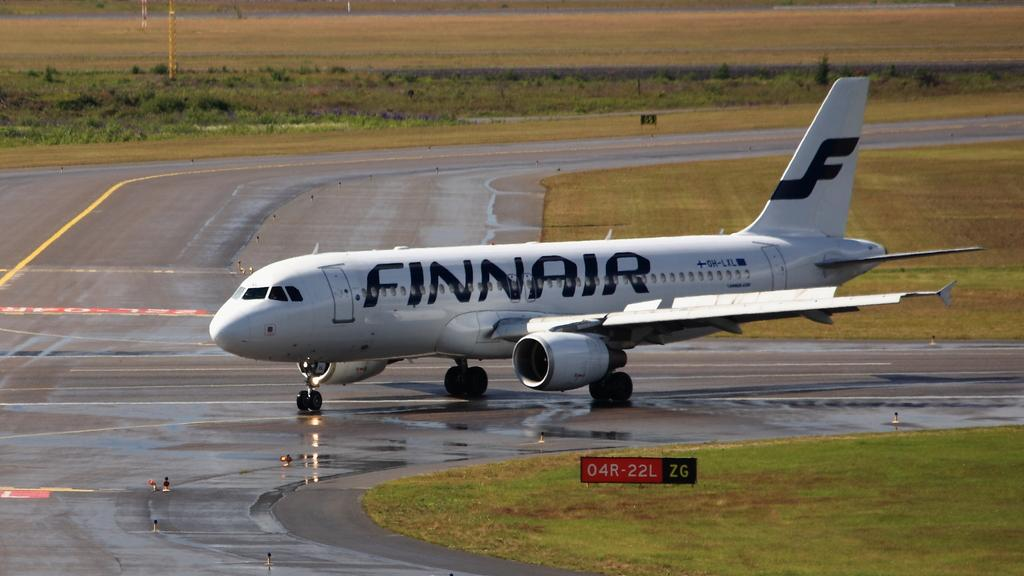<image>
Present a compact description of the photo's key features. A Finnair airplane taxis on a wet runway. 